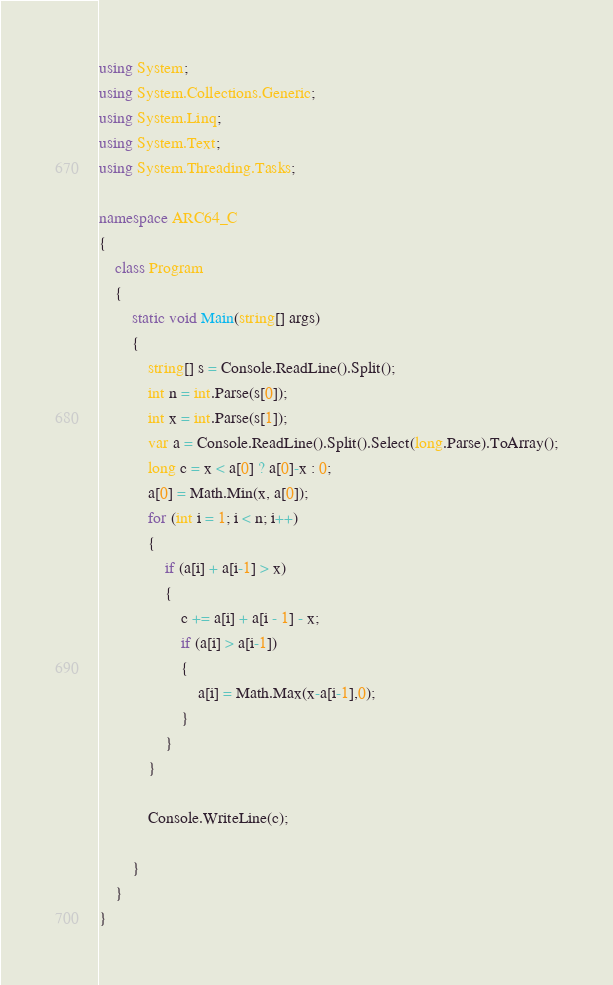Convert code to text. <code><loc_0><loc_0><loc_500><loc_500><_C#_>using System;
using System.Collections.Generic;
using System.Linq;
using System.Text;
using System.Threading.Tasks;

namespace ARC64_C
{
    class Program
    {
        static void Main(string[] args)
        {
            string[] s = Console.ReadLine().Split();
            int n = int.Parse(s[0]);
            int x = int.Parse(s[1]);
            var a = Console.ReadLine().Split().Select(long.Parse).ToArray();
            long c = x < a[0] ? a[0]-x : 0;
            a[0] = Math.Min(x, a[0]);
            for (int i = 1; i < n; i++)
            {
                if (a[i] + a[i-1] > x)
                {
                    c += a[i] + a[i - 1] - x;
                    if (a[i] > a[i-1])
                    {
                        a[i] = Math.Max(x-a[i-1],0);
                    }
                }
            }

            Console.WriteLine(c);

        }
    }
}
</code> 